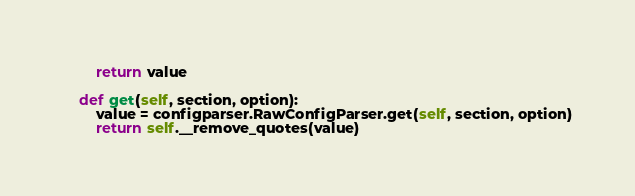<code> <loc_0><loc_0><loc_500><loc_500><_Python_>        return value

    def get(self, section, option):
        value = configparser.RawConfigParser.get(self, section, option)
        return self.__remove_quotes(value)
</code> 